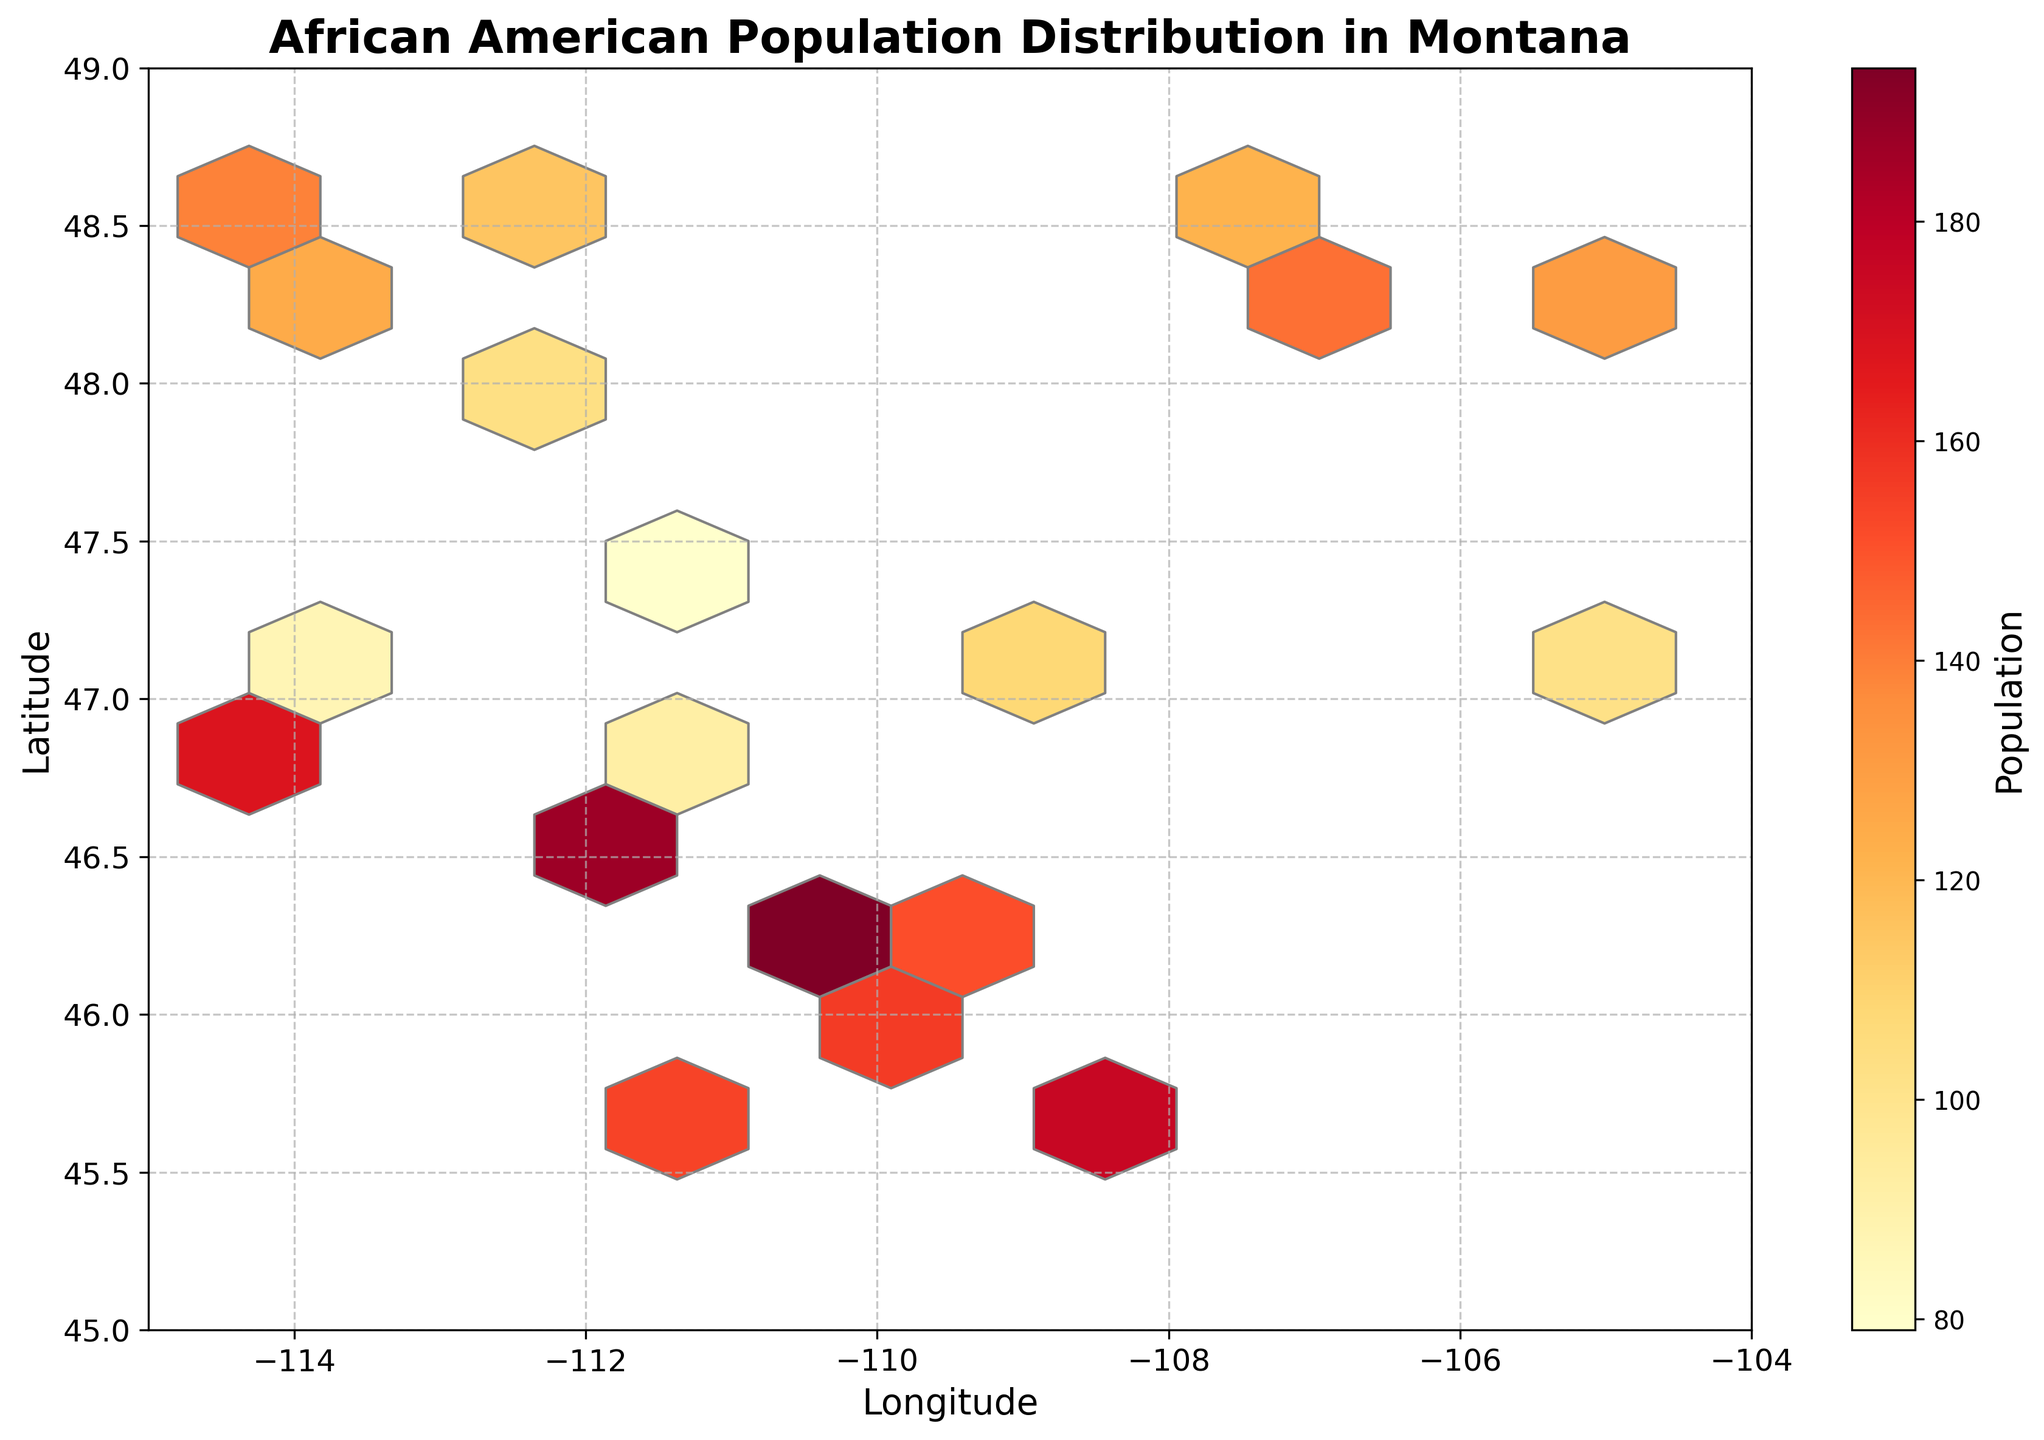Which direction represents the longitude on the plot? On the hexbin plot, the x-axis represents longitude, providing the horizontal position of each point.
Answer: Horizontal What color indicates the highest population in the hexagons? The color map used in the hexbin plot is 'YlOrRd', which means "Yellow to Orange to Red". The darkest red indicates the highest population.
Answer: Darkest Red How does the latitude variation appear on the plot? The y-axis represents latitude, displaying the vertical position which increases from the bottom to the top of the plot.
Answer: Vertical Which Montana city or town has the highest African American population based on the plot? The plot is colored based on population density, and the hexagon with the darkest red color at coordinates around (-111.83, 45.67) indicates the highest African American population. The data indicates it is Livingston with 210 people.
Answer: Livingston How does the color bar help in understanding the distribution on the plot? The color bar on the right side of the plot shows a gradient from yellow to dark red which corresponds to increasing population density in the hexagons.
Answer: It maps color to population Is there any spatial clustering of African American populations in Montana shown on the plot? The plot shows dense clusters of darker red hexagons in specific regions around (-111, 46) and (-108, 45.78), indicating spatial clustering of higher populations in those areas.
Answer: Yes Are there more cities with lower African American populations or higher African American populations according to the plot? The plot shows more hexagons with yellow to light orange colors compared to dark red, indicating a higher number of cities with lower African American populations.
Answer: Lower populations Does any area have no African American population according to the plot? The plot has gray areas (no hexagons) where there are no recorded data points, indicating regions with no African American population.
Answer: Yes Which region of Montana (north or south, east or west) has a higher concentration of African American populations? The darkest red hexagons, indicating higher concentrations, are predominantly found in the southwestern region of Montana.
Answer: Southwestern What's the average population size for African Americans in the cities and towns shown on the plot? To find the average: sum all population values (125+98+210+...+103) which equals 2,586, and divide by the number of data points (20). The average is 2,586 / 20 = 129.3.
Answer: 129.3 